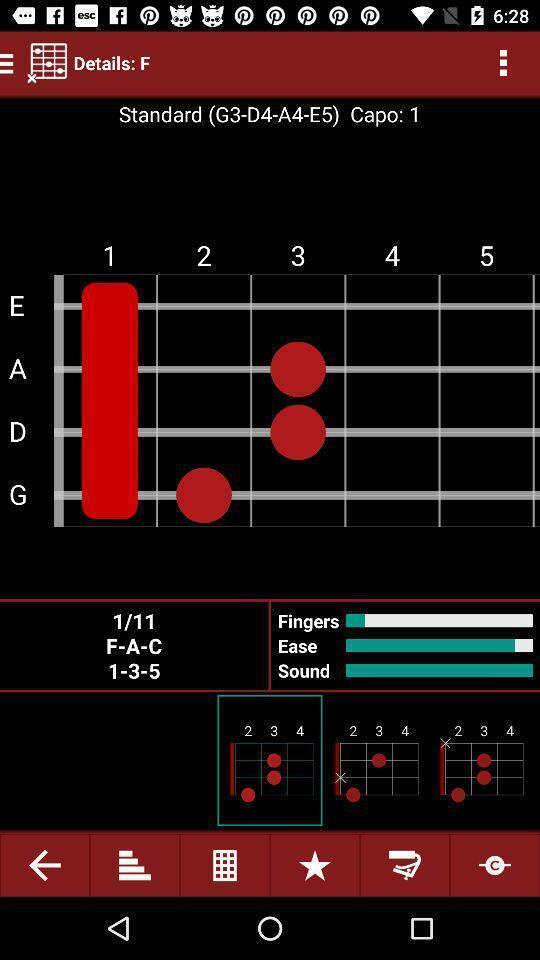Summarize the main components in this picture. Page shows the chords of finger and sound details. 